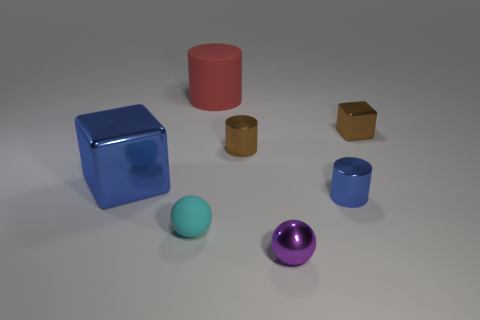Are these objects arranged in any particular pattern or order? The objects do not appear to be arranged in a specific pattern or order. They are scattered across the surface in a manner that seems random, which could suggest an artistic or experimental setup rather than a functional one. 